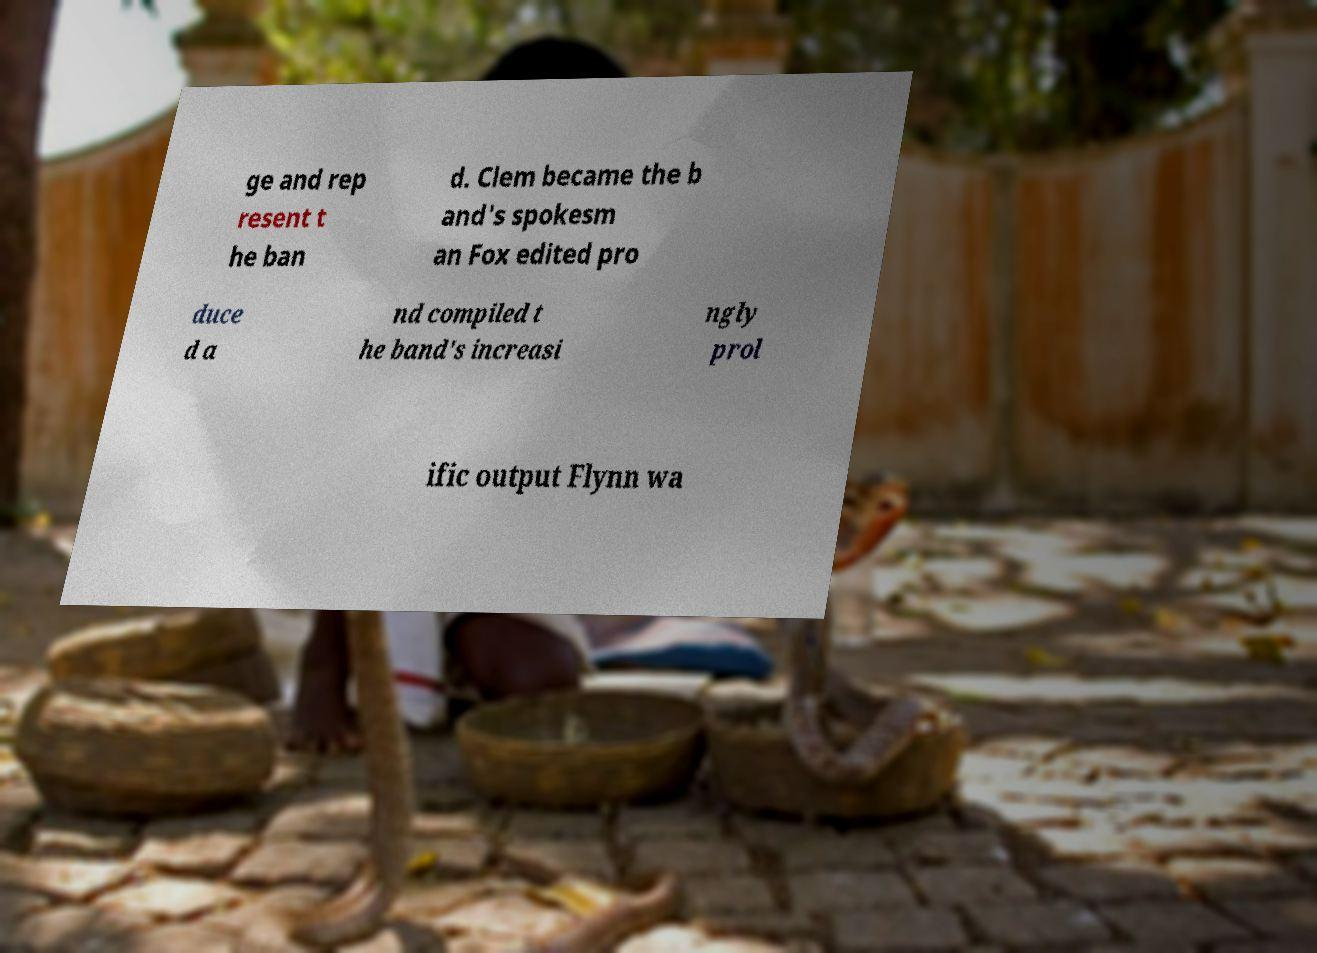Could you extract and type out the text from this image? ge and rep resent t he ban d. Clem became the b and's spokesm an Fox edited pro duce d a nd compiled t he band's increasi ngly prol ific output Flynn wa 